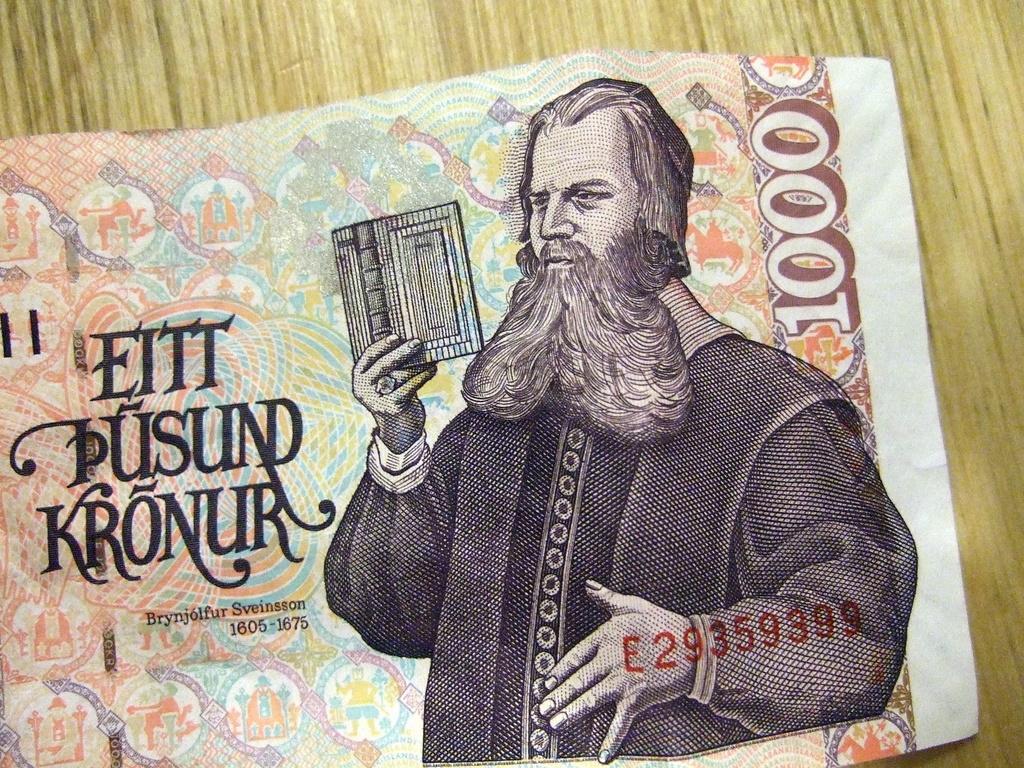How would you summarize this image in a sentence or two? In this image, I can see a kronur banknote on a wooden object. 